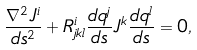<formula> <loc_0><loc_0><loc_500><loc_500>\frac { \nabla ^ { 2 } J ^ { i } } { d s ^ { 2 } } + R _ { j k l } ^ { i } \frac { d q ^ { j } } { d s } J ^ { k } \frac { d q ^ { l } } { d s } = 0 ,</formula> 